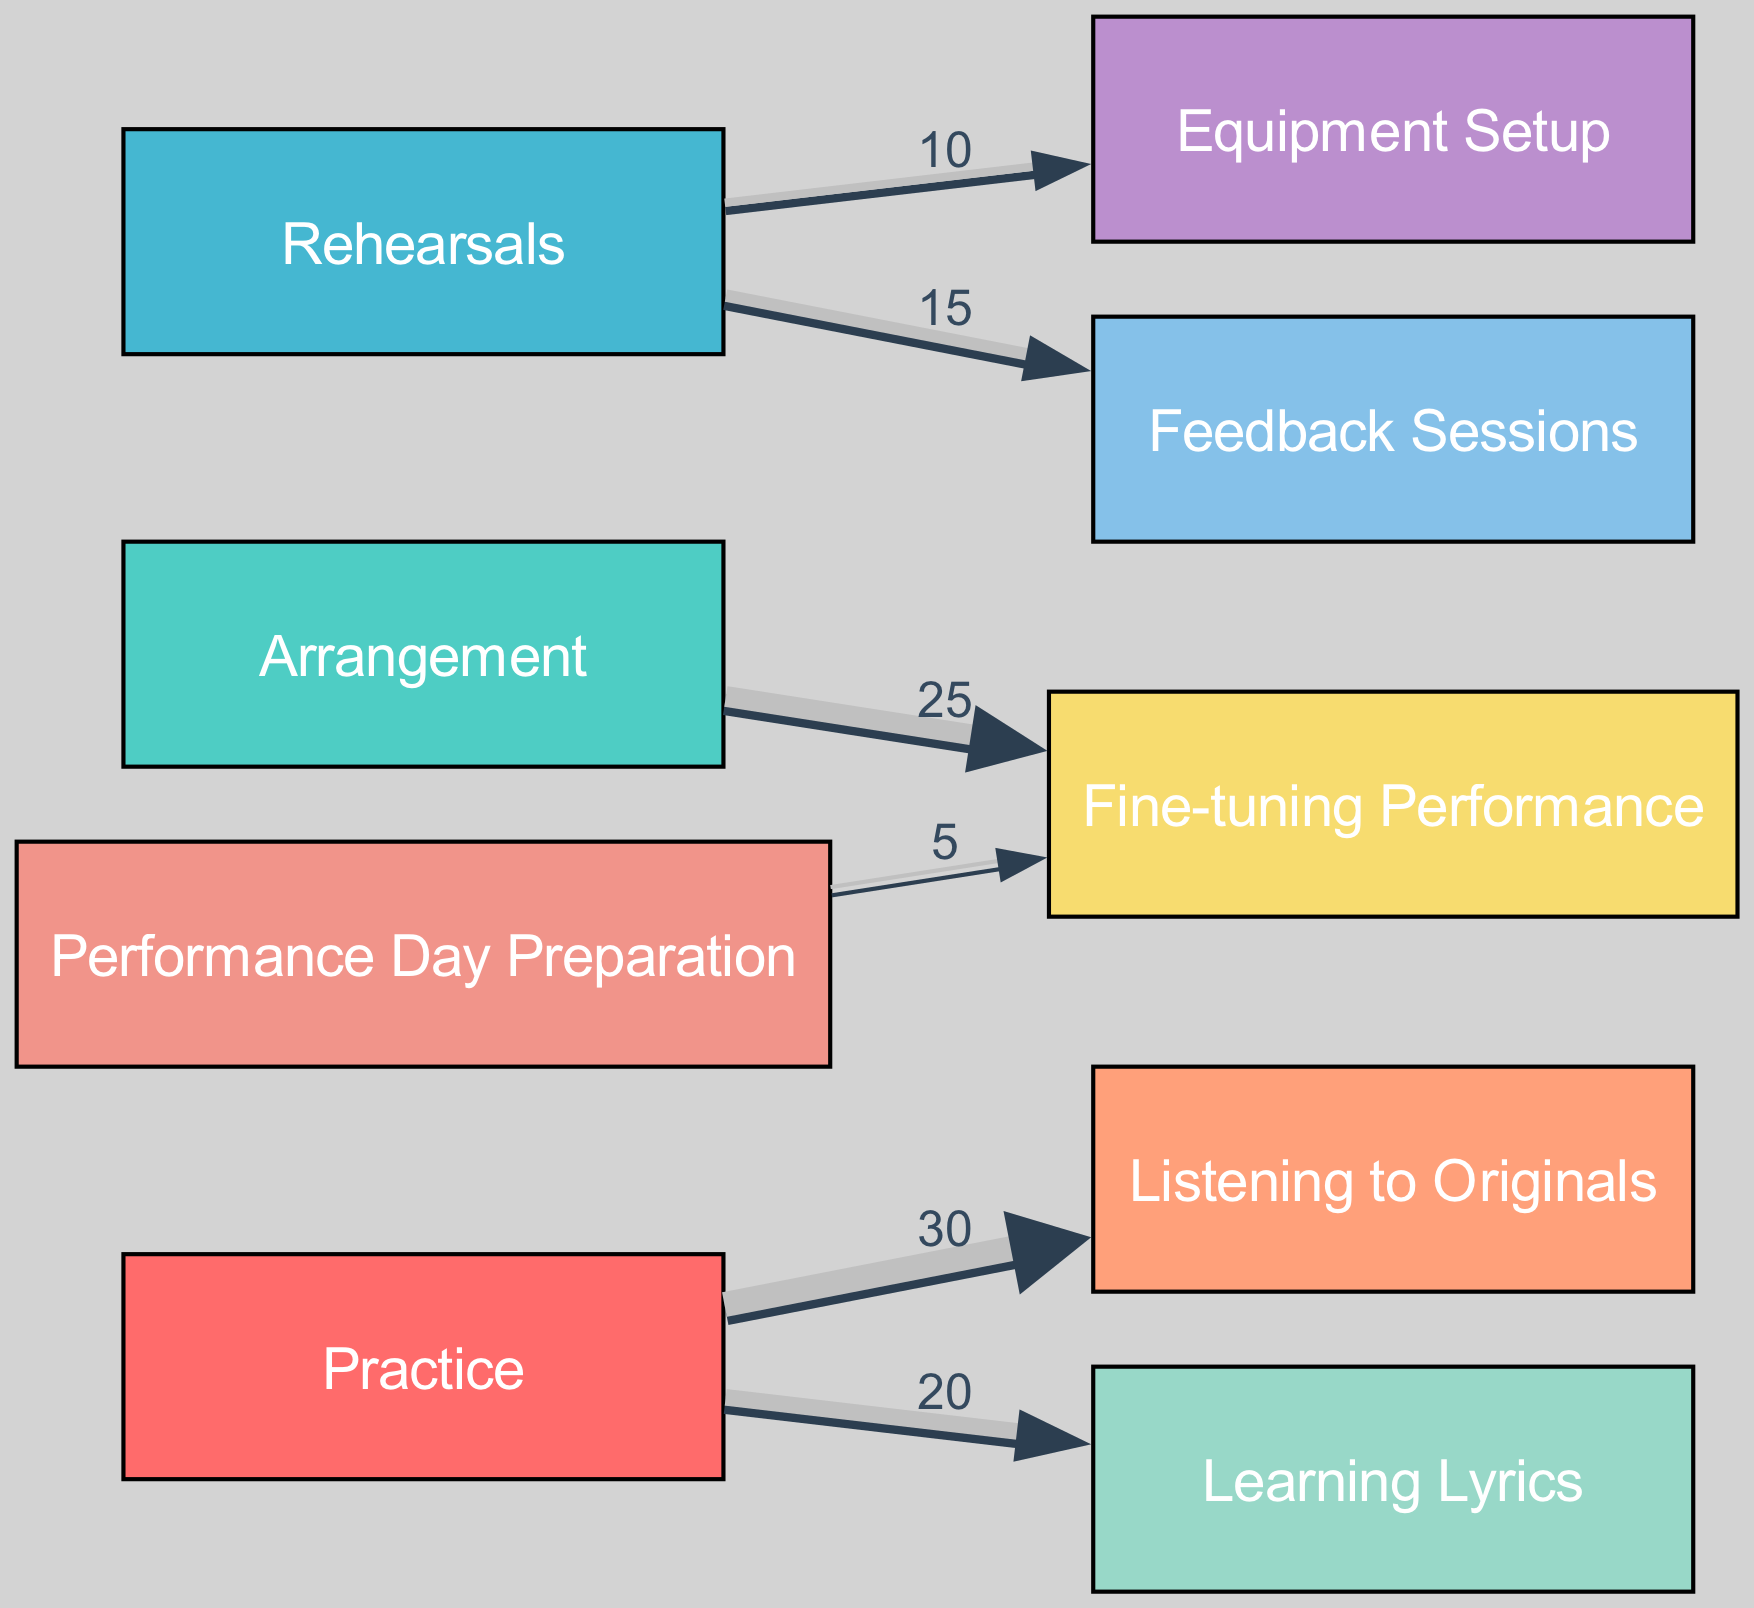What is the total flow from Practice to Listening to Originals? The flow from Practice to Listening to Originals is directly given in the links section, which states a value of 30. Therefore, the total flow is simply the value associated with that link.
Answer: 30 How many total nodes are present in the diagram? By counting the nodes listed in the nodes section, we find there are 9 unique nodes present in the diagram. This number represents the different aspects of music preparation.
Answer: 9 What is the flow value from Arrangement to Fine-tuning Performance? The link between Arrangement and Fine-tuning Performance has a specified value of 25. This value indicates the amount of time or effort flowing from Arrangement to Fine-tuning Performance.
Answer: 25 What are the two sources that contribute flow to Equipment Setup? The diagram shows that Rehearsals is the only source contributing to Equipment Setup with a flow value of 10. Thus, there is one source: Rehearsals.
Answer: Rehearsals What is the total value of flows from Rehearsals? To calculate the total flow from Rehearsals, we add the values of the two links: 15 (to Feedback Sessions) and 10 (to Equipment Setup), giving a total of 25 flowing out.
Answer: 25 What is the relationship between Performance Day Preparation and Fine-tuning Performance? The diagram indicates a direct flow from Performance Day Preparation to Fine-tuning Performance with a value of 5, showing that the preparation directly contributes to fine-tuning.
Answer: 5 Which node has the smallest flow value in the diagram? By examining the flow values in all links, Performance Day Preparation to Fine-tuning Performance has the smallest value of 5. Thus, it is identified as the node with the least flow.
Answer: 5 How does Listening to Originals connect to the process of Practice? The diagram shows a direct flow from Practice to Listening to Originals with a value of 30, indicating that Listening to Originals is heavily influenced by Practice efforts.
Answer: 30 Which node receives flow from both Practice and Rehearsals? By analyzing the diagram, we find that Fine-tuning Performance receives flow from both Arrangement (25) and Performance Day Preparation (5). Rehearsals contributes only to other components.
Answer: Fine-tuning Performance 